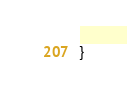<code> <loc_0><loc_0><loc_500><loc_500><_C++_>}

</code> 